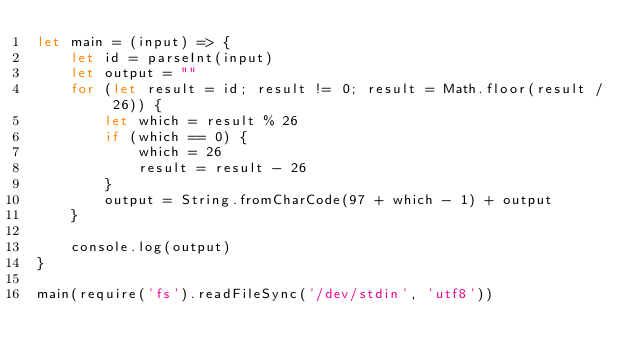<code> <loc_0><loc_0><loc_500><loc_500><_JavaScript_>let main = (input) => {
    let id = parseInt(input)
    let output = ""
    for (let result = id; result != 0; result = Math.floor(result / 26)) {
        let which = result % 26
        if (which == 0) {
            which = 26
            result = result - 26
        }
        output = String.fromCharCode(97 + which - 1) + output
    }

    console.log(output)
}

main(require('fs').readFileSync('/dev/stdin', 'utf8'))</code> 